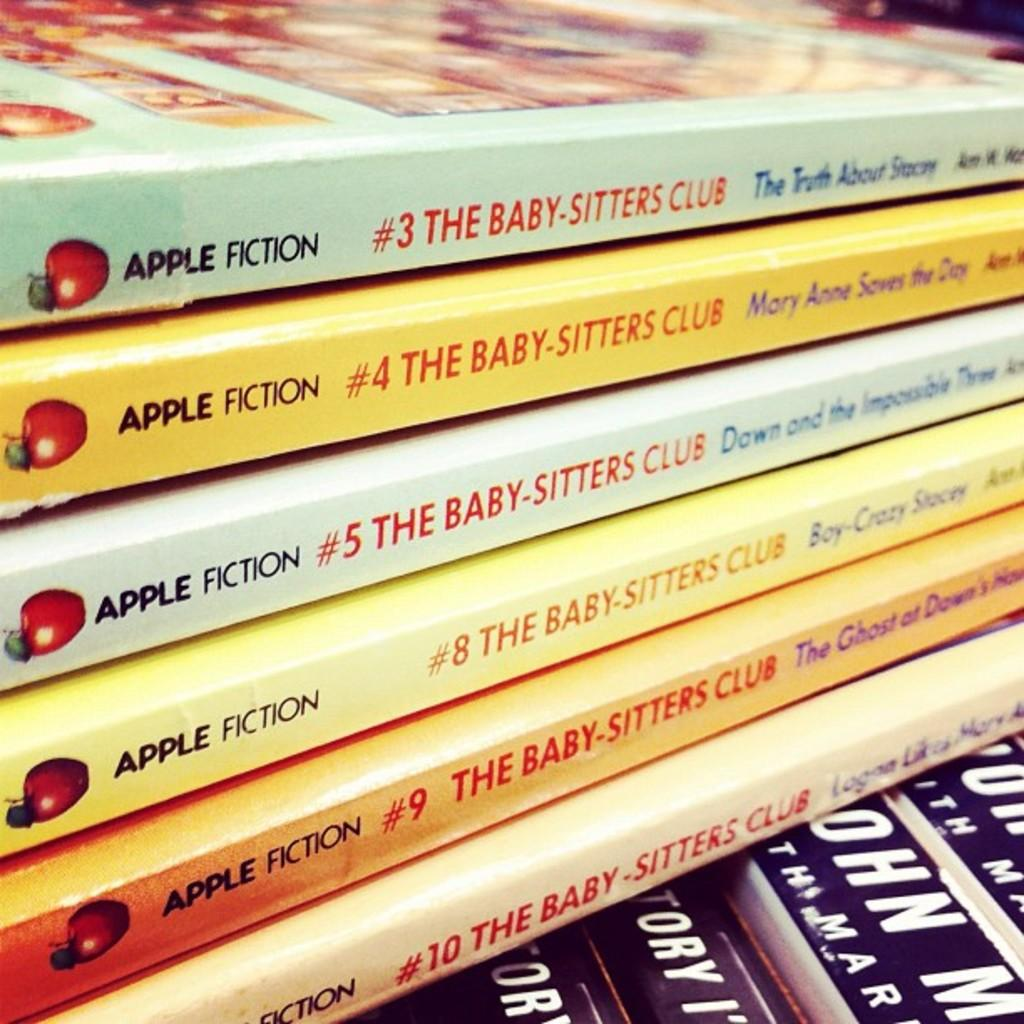<image>
Give a short and clear explanation of the subsequent image. A stack of The Baby Sitters Club books that are on top of other books. 